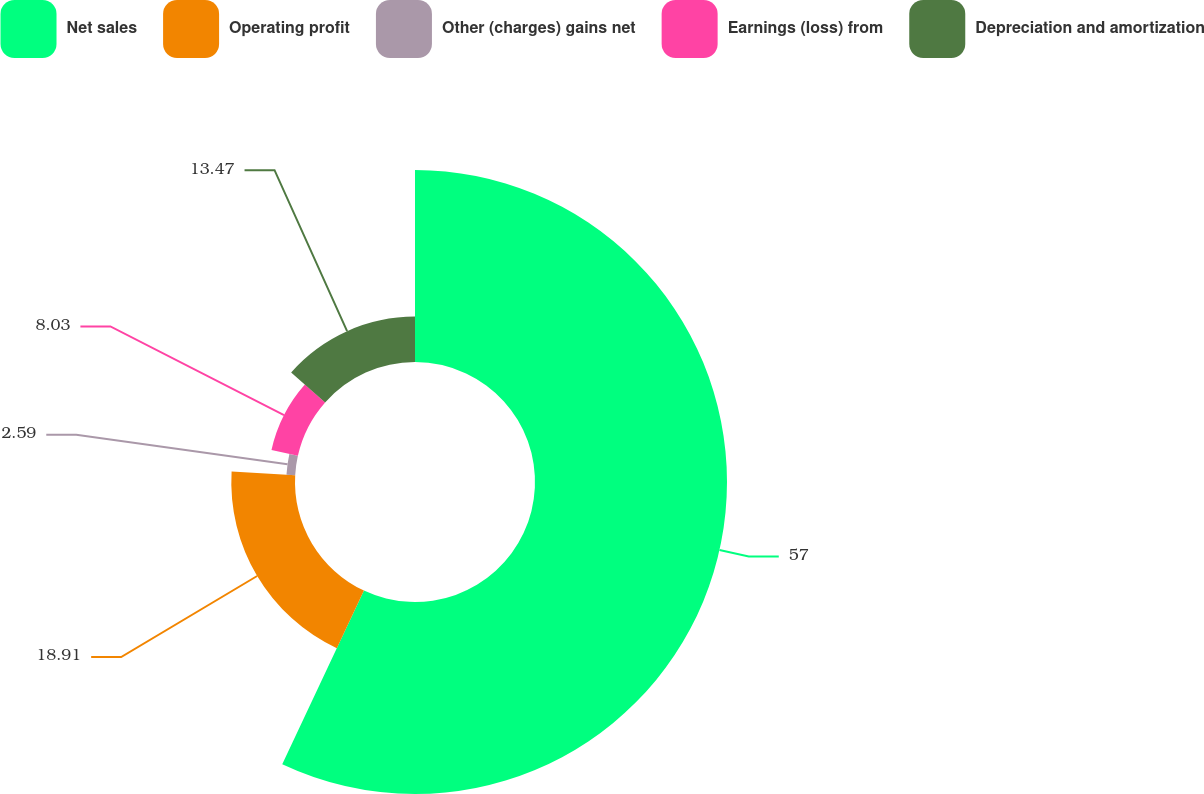Convert chart to OTSL. <chart><loc_0><loc_0><loc_500><loc_500><pie_chart><fcel>Net sales<fcel>Operating profit<fcel>Other (charges) gains net<fcel>Earnings (loss) from<fcel>Depreciation and amortization<nl><fcel>56.99%<fcel>18.91%<fcel>2.59%<fcel>8.03%<fcel>13.47%<nl></chart> 